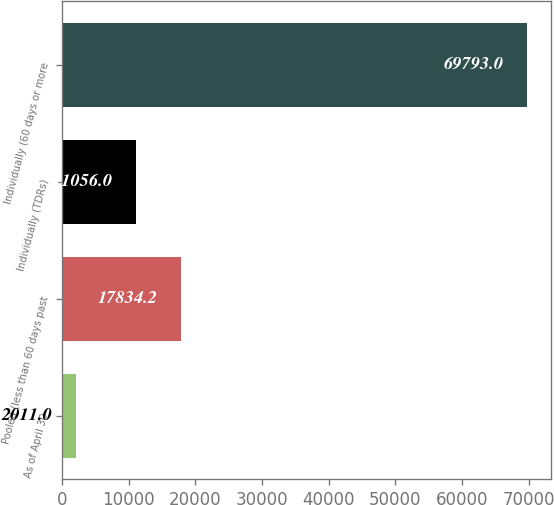Convert chart to OTSL. <chart><loc_0><loc_0><loc_500><loc_500><bar_chart><fcel>As of April 30<fcel>Pooled (less than 60 days past<fcel>Individually (TDRs)<fcel>Individually (60 days or more<nl><fcel>2011<fcel>17834.2<fcel>11056<fcel>69793<nl></chart> 